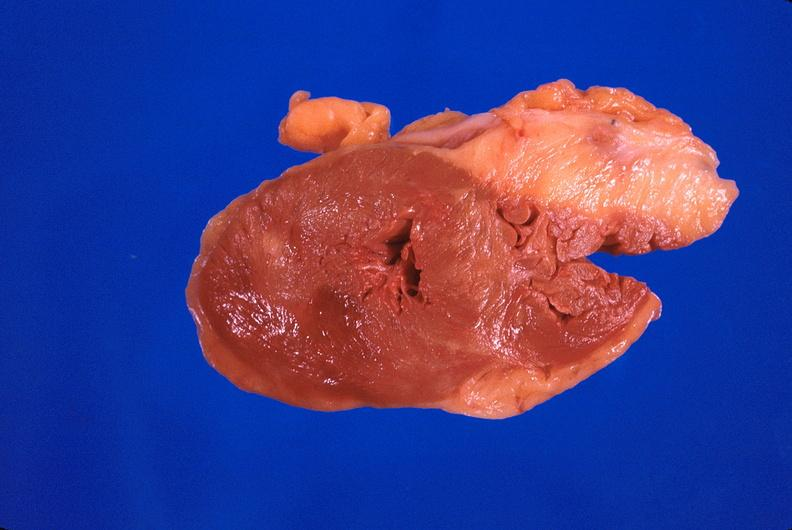s cardiovascular present?
Answer the question using a single word or phrase. Yes 